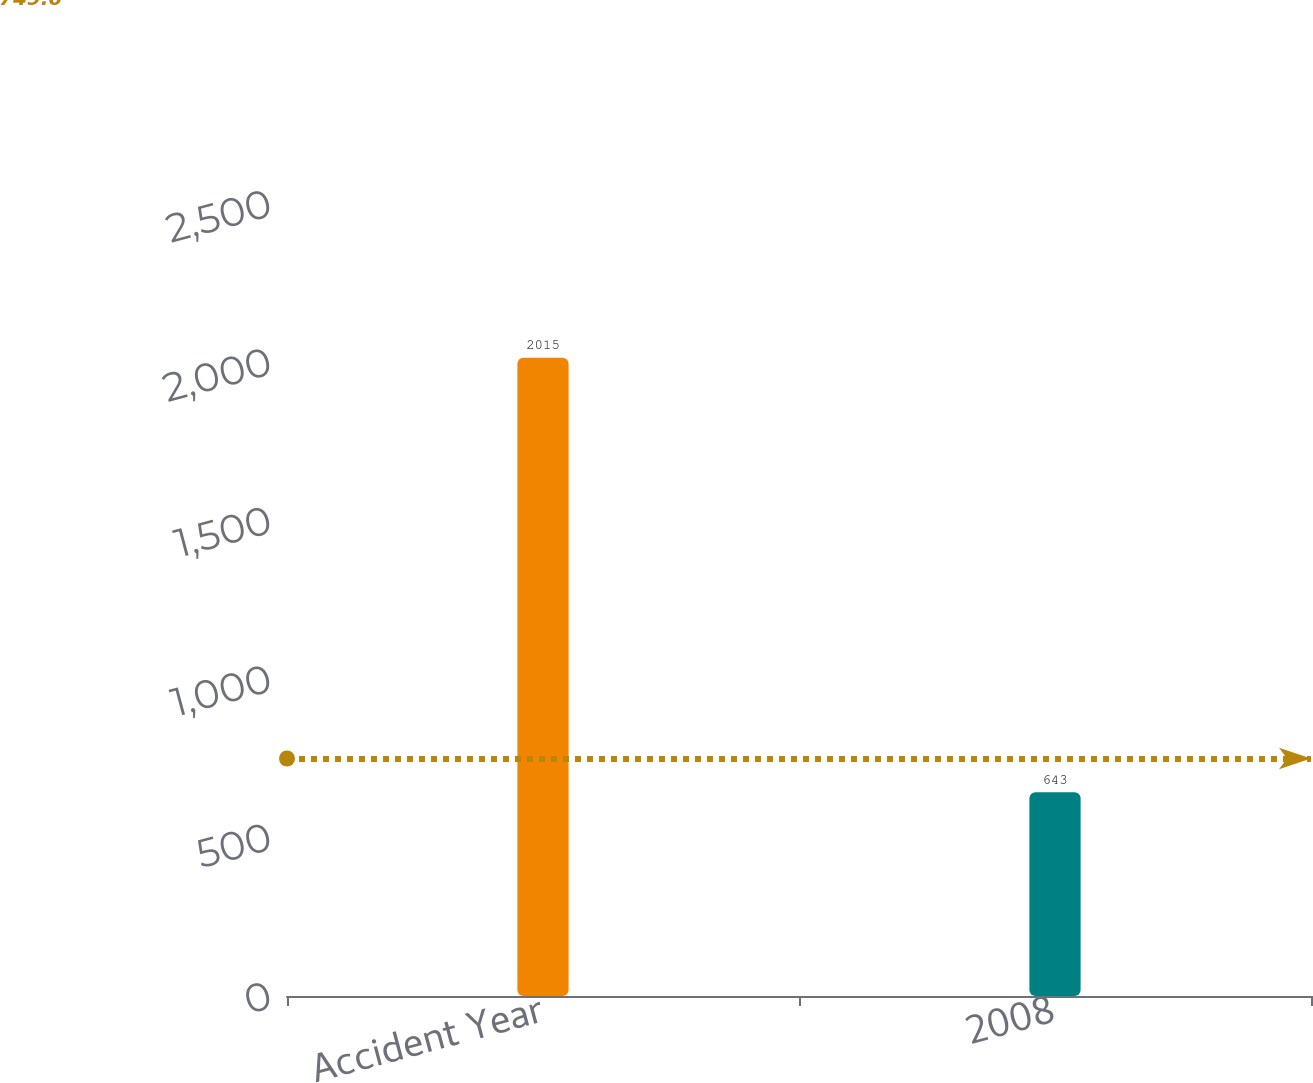<chart> <loc_0><loc_0><loc_500><loc_500><bar_chart><fcel>Accident Year<fcel>2008<nl><fcel>2015<fcel>643<nl></chart> 